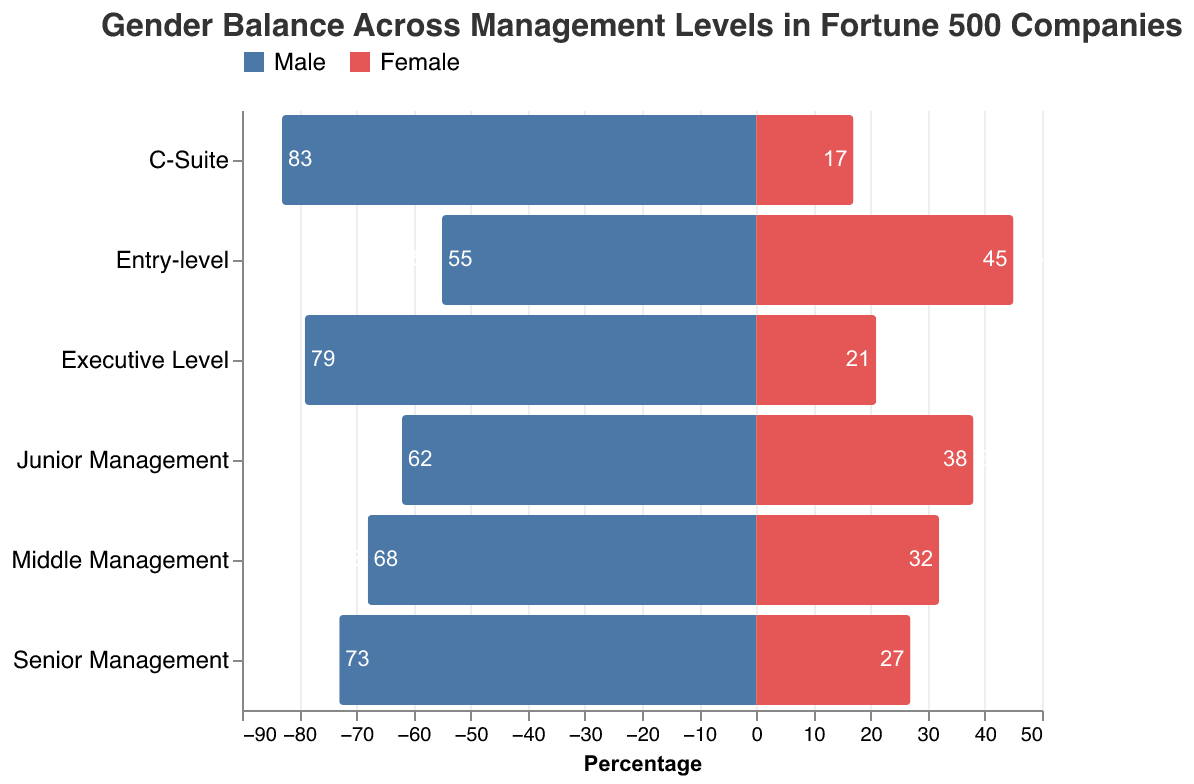What is the title of the chart? The title can be found at the top of the chart in larger, bold text. It reads: "Gender Balance Across Management Levels in Fortune 500 Companies."
Answer: Gender Balance Across Management Levels in Fortune 500 Companies What colors represent Male and Female in the chart? The color legend at the top of the chart indicates that Male is represented in blue and Female is represented in red.
Answer: Male: blue, Female: red At which management level is the gender balance closest to equal? By examining the lengths of the blue and red bars, the Entry-level management appears closest to equal with 55% male and 45% female.
Answer: Entry-level How many management levels are displayed in the chart? Counting the different categories along the vertical axis gives six management levels: Entry-level, Junior Management, Middle Management, Senior Management, Executive Level, and C-Suite.
Answer: Six Which management level has the highest percentage of males? By referring to the length of the blue bars, the C-Suite level has the highest percentage of males at 83%.
Answer: C-Suite What is the difference in percentage of males between Entry-level and C-Suite? Subtract the percentage of males in Entry-level (55%) from the percentage in the C-Suite (83%): 83% - 55% = 28%.
Answer: 28% What is the total percentage of females in Senior Management and Executive Level combined? Add the percentages of females in Senior Management (27%) and Executive Level (21%): 27% + 21% = 48%.
Answer: 48% How does the percentage of females change from Entry-level to Executive Level? The percentage of females decreases from 45% at Entry-level to 21% at Executive Level. This represents a decrease of 45% - 21% = 24%.
Answer: Decreases by 24% Between which management levels is the gender disparity most significant? The disparity can be seen by the difference in male and female percentages. The C-Suite has the most significant disparity with 83% male and 17% female, creating a 66% difference.
Answer: C-Suite Is there a management level where the female representation is over 40%? Checking the red bar lengths, only the Entry-level has a female representation of 45%, which is over 40%.
Answer: Entry-level 